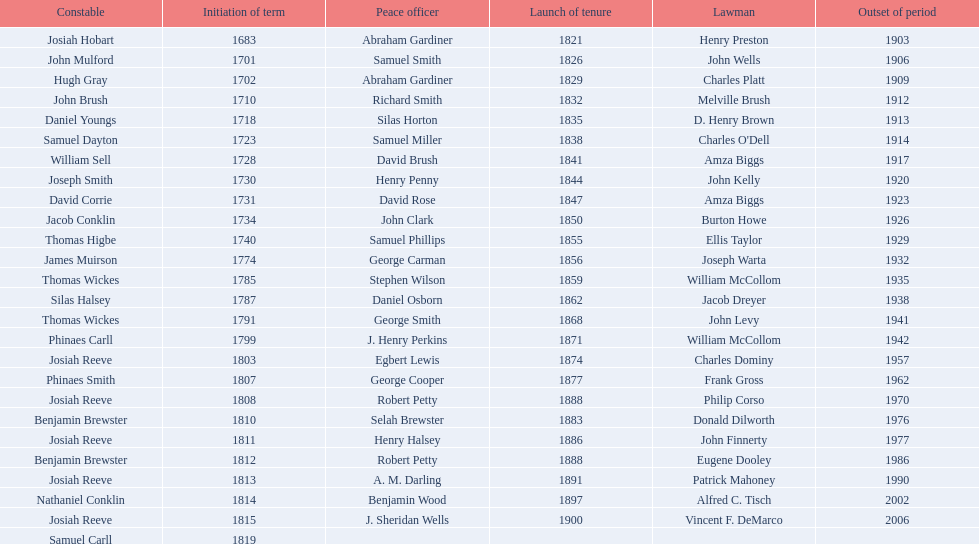Did robert petty serve before josiah reeve? No. Would you be able to parse every entry in this table? {'header': ['Constable', 'Initiation of term', 'Peace officer', 'Launch of tenure', 'Lawman', 'Outset of period'], 'rows': [['Josiah Hobart', '1683', 'Abraham Gardiner', '1821', 'Henry Preston', '1903'], ['John Mulford', '1701', 'Samuel Smith', '1826', 'John Wells', '1906'], ['Hugh Gray', '1702', 'Abraham Gardiner', '1829', 'Charles Platt', '1909'], ['John Brush', '1710', 'Richard Smith', '1832', 'Melville Brush', '1912'], ['Daniel Youngs', '1718', 'Silas Horton', '1835', 'D. Henry Brown', '1913'], ['Samuel Dayton', '1723', 'Samuel Miller', '1838', "Charles O'Dell", '1914'], ['William Sell', '1728', 'David Brush', '1841', 'Amza Biggs', '1917'], ['Joseph Smith', '1730', 'Henry Penny', '1844', 'John Kelly', '1920'], ['David Corrie', '1731', 'David Rose', '1847', 'Amza Biggs', '1923'], ['Jacob Conklin', '1734', 'John Clark', '1850', 'Burton Howe', '1926'], ['Thomas Higbe', '1740', 'Samuel Phillips', '1855', 'Ellis Taylor', '1929'], ['James Muirson', '1774', 'George Carman', '1856', 'Joseph Warta', '1932'], ['Thomas Wickes', '1785', 'Stephen Wilson', '1859', 'William McCollom', '1935'], ['Silas Halsey', '1787', 'Daniel Osborn', '1862', 'Jacob Dreyer', '1938'], ['Thomas Wickes', '1791', 'George Smith', '1868', 'John Levy', '1941'], ['Phinaes Carll', '1799', 'J. Henry Perkins', '1871', 'William McCollom', '1942'], ['Josiah Reeve', '1803', 'Egbert Lewis', '1874', 'Charles Dominy', '1957'], ['Phinaes Smith', '1807', 'George Cooper', '1877', 'Frank Gross', '1962'], ['Josiah Reeve', '1808', 'Robert Petty', '1888', 'Philip Corso', '1970'], ['Benjamin Brewster', '1810', 'Selah Brewster', '1883', 'Donald Dilworth', '1976'], ['Josiah Reeve', '1811', 'Henry Halsey', '1886', 'John Finnerty', '1977'], ['Benjamin Brewster', '1812', 'Robert Petty', '1888', 'Eugene Dooley', '1986'], ['Josiah Reeve', '1813', 'A. M. Darling', '1891', 'Patrick Mahoney', '1990'], ['Nathaniel Conklin', '1814', 'Benjamin Wood', '1897', 'Alfred C. Tisch', '2002'], ['Josiah Reeve', '1815', 'J. Sheridan Wells', '1900', 'Vincent F. DeMarco', '2006'], ['Samuel Carll', '1819', '', '', '', '']]} 